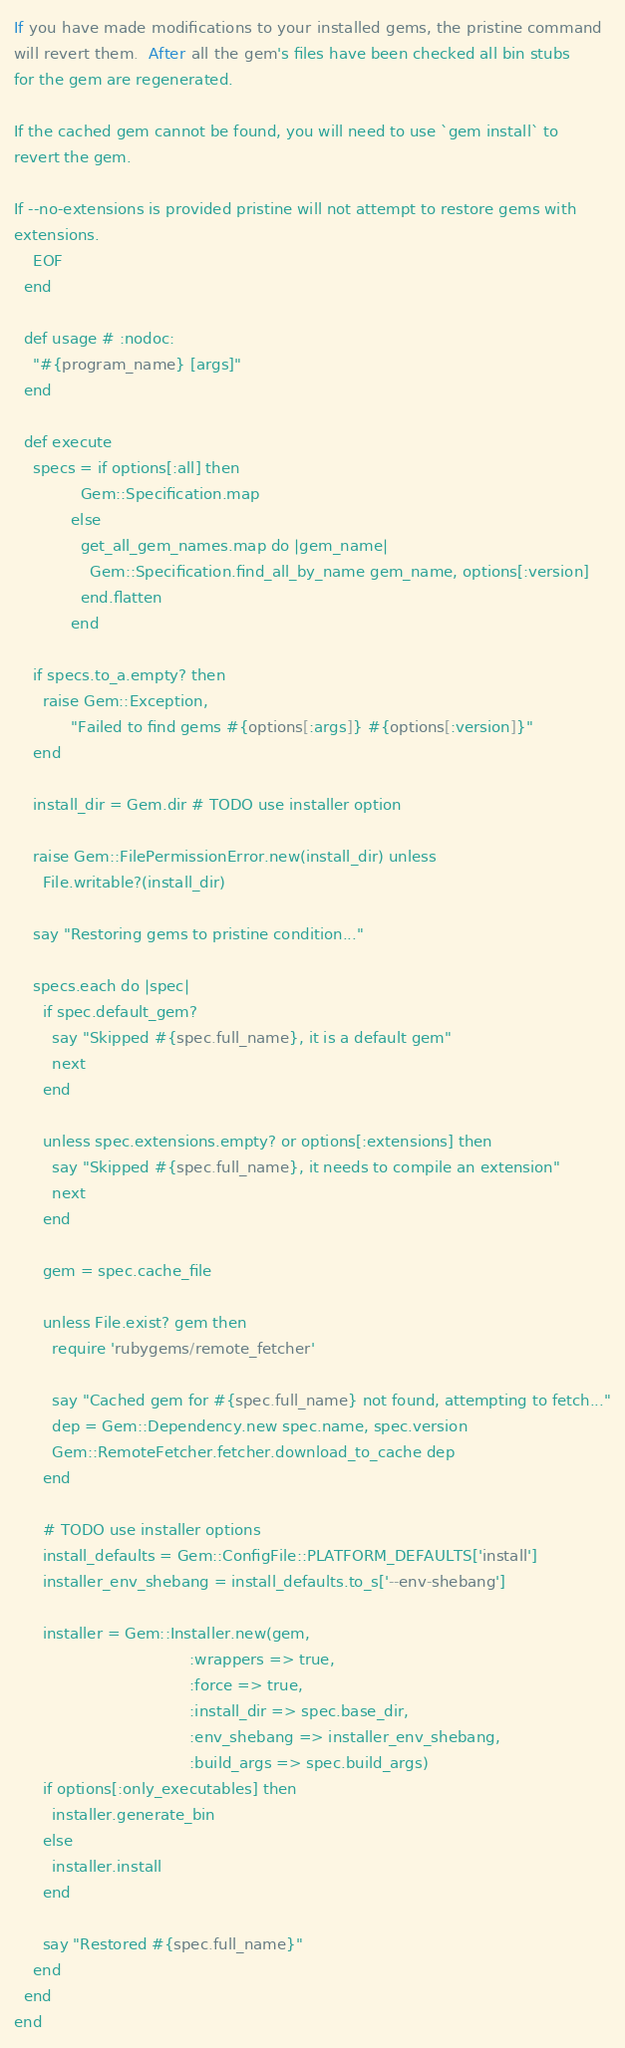Convert code to text. <code><loc_0><loc_0><loc_500><loc_500><_Ruby_>
If you have made modifications to your installed gems, the pristine command
will revert them.  After all the gem's files have been checked all bin stubs
for the gem are regenerated.

If the cached gem cannot be found, you will need to use `gem install` to
revert the gem.

If --no-extensions is provided pristine will not attempt to restore gems with
extensions.
    EOF
  end

  def usage # :nodoc:
    "#{program_name} [args]"
  end

  def execute
    specs = if options[:all] then
              Gem::Specification.map
            else
              get_all_gem_names.map do |gem_name|
                Gem::Specification.find_all_by_name gem_name, options[:version]
              end.flatten
            end

    if specs.to_a.empty? then
      raise Gem::Exception,
            "Failed to find gems #{options[:args]} #{options[:version]}"
    end

    install_dir = Gem.dir # TODO use installer option

    raise Gem::FilePermissionError.new(install_dir) unless
      File.writable?(install_dir)

    say "Restoring gems to pristine condition..."

    specs.each do |spec|
      if spec.default_gem?
        say "Skipped #{spec.full_name}, it is a default gem"
        next
      end

      unless spec.extensions.empty? or options[:extensions] then
        say "Skipped #{spec.full_name}, it needs to compile an extension"
        next
      end

      gem = spec.cache_file

      unless File.exist? gem then
        require 'rubygems/remote_fetcher'

        say "Cached gem for #{spec.full_name} not found, attempting to fetch..."
        dep = Gem::Dependency.new spec.name, spec.version
        Gem::RemoteFetcher.fetcher.download_to_cache dep
      end

      # TODO use installer options
      install_defaults = Gem::ConfigFile::PLATFORM_DEFAULTS['install']
      installer_env_shebang = install_defaults.to_s['--env-shebang']

      installer = Gem::Installer.new(gem,
                                     :wrappers => true,
                                     :force => true,
                                     :install_dir => spec.base_dir,
                                     :env_shebang => installer_env_shebang,
                                     :build_args => spec.build_args)
      if options[:only_executables] then
        installer.generate_bin
      else
        installer.install
      end

      say "Restored #{spec.full_name}"
    end
  end
end
</code> 